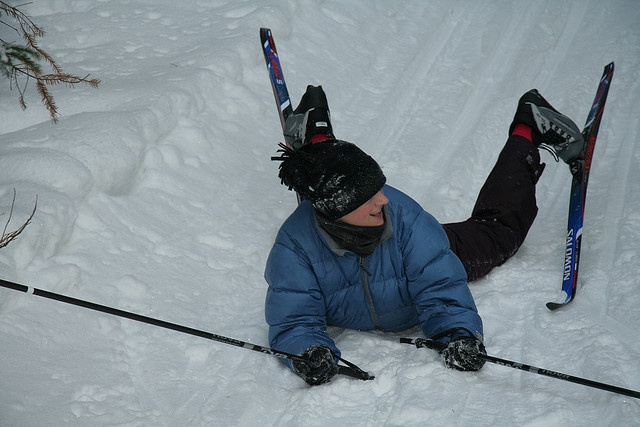Describe the objects in this image and their specific colors. I can see people in gray, black, blue, and navy tones and skis in gray, black, darkgray, and navy tones in this image. 